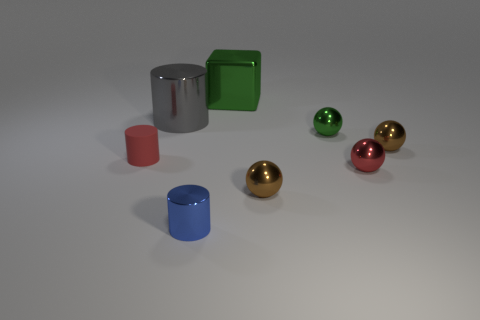What color is the tiny object that is both to the left of the green block and to the right of the small matte cylinder?
Make the answer very short. Blue. The small brown sphere in front of the brown metal object that is to the right of the tiny green ball is made of what material?
Keep it short and to the point. Metal. What is the size of the other blue object that is the same shape as the tiny matte thing?
Provide a short and direct response. Small. Does the tiny thing left of the tiny blue metal cylinder have the same color as the cube?
Make the answer very short. No. Are there fewer blue things than large metal spheres?
Your answer should be compact. No. What number of other things are the same color as the block?
Your response must be concise. 1. Is the material of the green thing to the right of the metal block the same as the small blue object?
Offer a terse response. Yes. There is a small red thing on the right side of the small green sphere; what is it made of?
Keep it short and to the point. Metal. What is the size of the red object on the right side of the small cylinder that is in front of the tiny red matte cylinder?
Ensure brevity in your answer.  Small. Is there a small green ball made of the same material as the big cylinder?
Keep it short and to the point. Yes. 